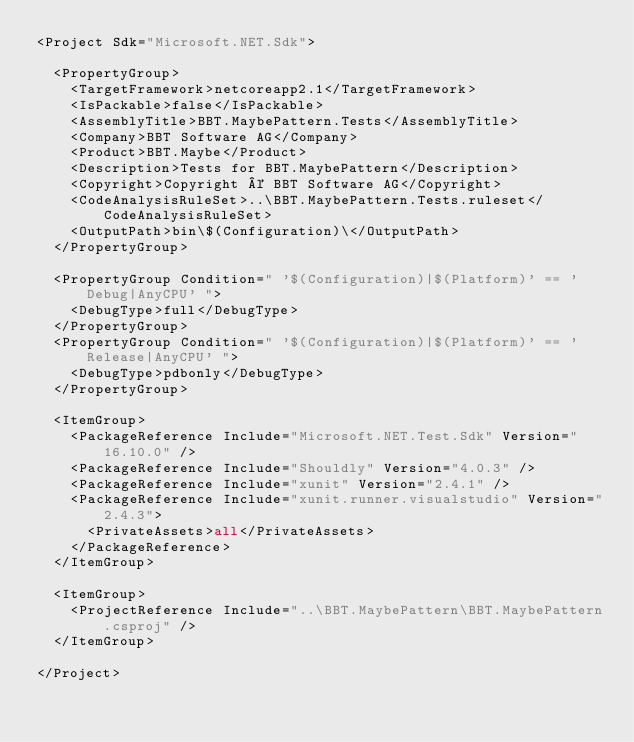<code> <loc_0><loc_0><loc_500><loc_500><_XML_><Project Sdk="Microsoft.NET.Sdk">

  <PropertyGroup>
    <TargetFramework>netcoreapp2.1</TargetFramework>
    <IsPackable>false</IsPackable>
    <AssemblyTitle>BBT.MaybePattern.Tests</AssemblyTitle>
    <Company>BBT Software AG</Company>
    <Product>BBT.Maybe</Product>
    <Description>Tests for BBT.MaybePattern</Description>
    <Copyright>Copyright © BBT Software AG</Copyright>
    <CodeAnalysisRuleSet>..\BBT.MaybePattern.Tests.ruleset</CodeAnalysisRuleSet>
    <OutputPath>bin\$(Configuration)\</OutputPath>
  </PropertyGroup>

  <PropertyGroup Condition=" '$(Configuration)|$(Platform)' == 'Debug|AnyCPU' ">
    <DebugType>full</DebugType>
  </PropertyGroup>
  <PropertyGroup Condition=" '$(Configuration)|$(Platform)' == 'Release|AnyCPU' ">
    <DebugType>pdbonly</DebugType>
  </PropertyGroup>

  <ItemGroup>
    <PackageReference Include="Microsoft.NET.Test.Sdk" Version="16.10.0" />
    <PackageReference Include="Shouldly" Version="4.0.3" />
    <PackageReference Include="xunit" Version="2.4.1" />
    <PackageReference Include="xunit.runner.visualstudio" Version="2.4.3">
      <PrivateAssets>all</PrivateAssets>
    </PackageReference>
  </ItemGroup>

  <ItemGroup>
    <ProjectReference Include="..\BBT.MaybePattern\BBT.MaybePattern.csproj" />
  </ItemGroup>

</Project>
</code> 